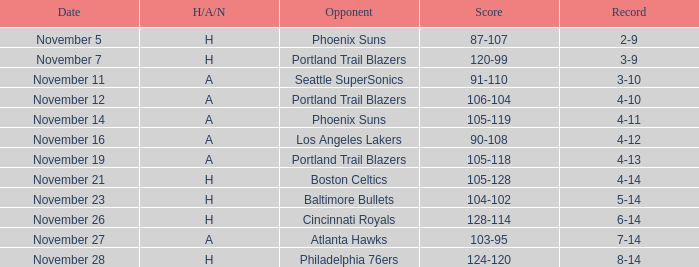Parse the table in full. {'header': ['Date', 'H/A/N', 'Opponent', 'Score', 'Record'], 'rows': [['November 5', 'H', 'Phoenix Suns', '87-107', '2-9'], ['November 7', 'H', 'Portland Trail Blazers', '120-99', '3-9'], ['November 11', 'A', 'Seattle SuperSonics', '91-110', '3-10'], ['November 12', 'A', 'Portland Trail Blazers', '106-104', '4-10'], ['November 14', 'A', 'Phoenix Suns', '105-119', '4-11'], ['November 16', 'A', 'Los Angeles Lakers', '90-108', '4-12'], ['November 19', 'A', 'Portland Trail Blazers', '105-118', '4-13'], ['November 21', 'H', 'Boston Celtics', '105-128', '4-14'], ['November 23', 'H', 'Baltimore Bullets', '104-102', '5-14'], ['November 26', 'H', 'Cincinnati Royals', '128-114', '6-14'], ['November 27', 'A', 'Atlanta Hawks', '103-95', '7-14'], ['November 28', 'H', 'Philadelphia 76ers', '124-120', '8-14']]} When the cavaliers' record stood at 3-9, which team were they facing? Portland Trail Blazers. 